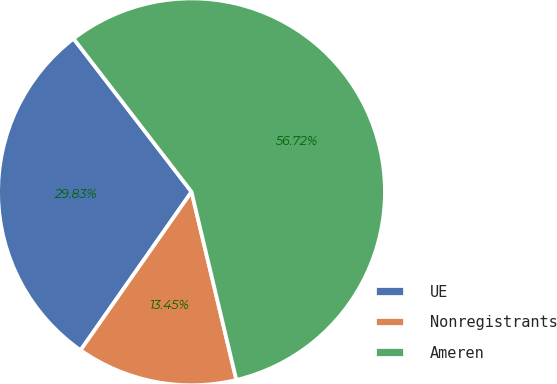Convert chart. <chart><loc_0><loc_0><loc_500><loc_500><pie_chart><fcel>UE<fcel>Nonregistrants<fcel>Ameren<nl><fcel>29.83%<fcel>13.45%<fcel>56.72%<nl></chart> 